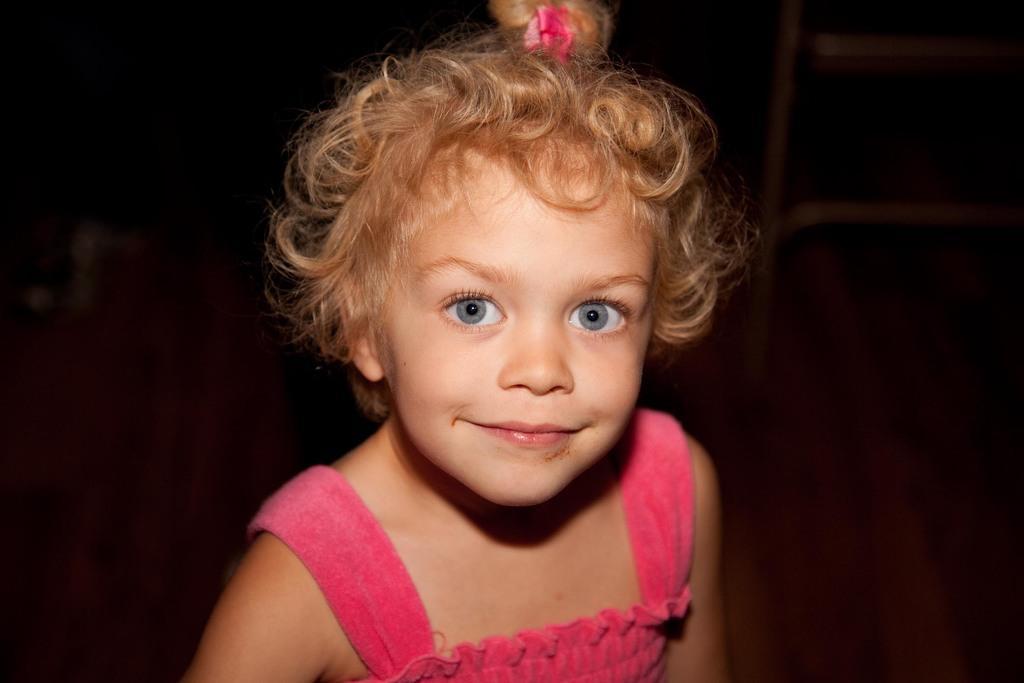Can you describe this image briefly? In this image I can see a girl is smiling, she wore pink color dress and a pink color hair ribbon. 